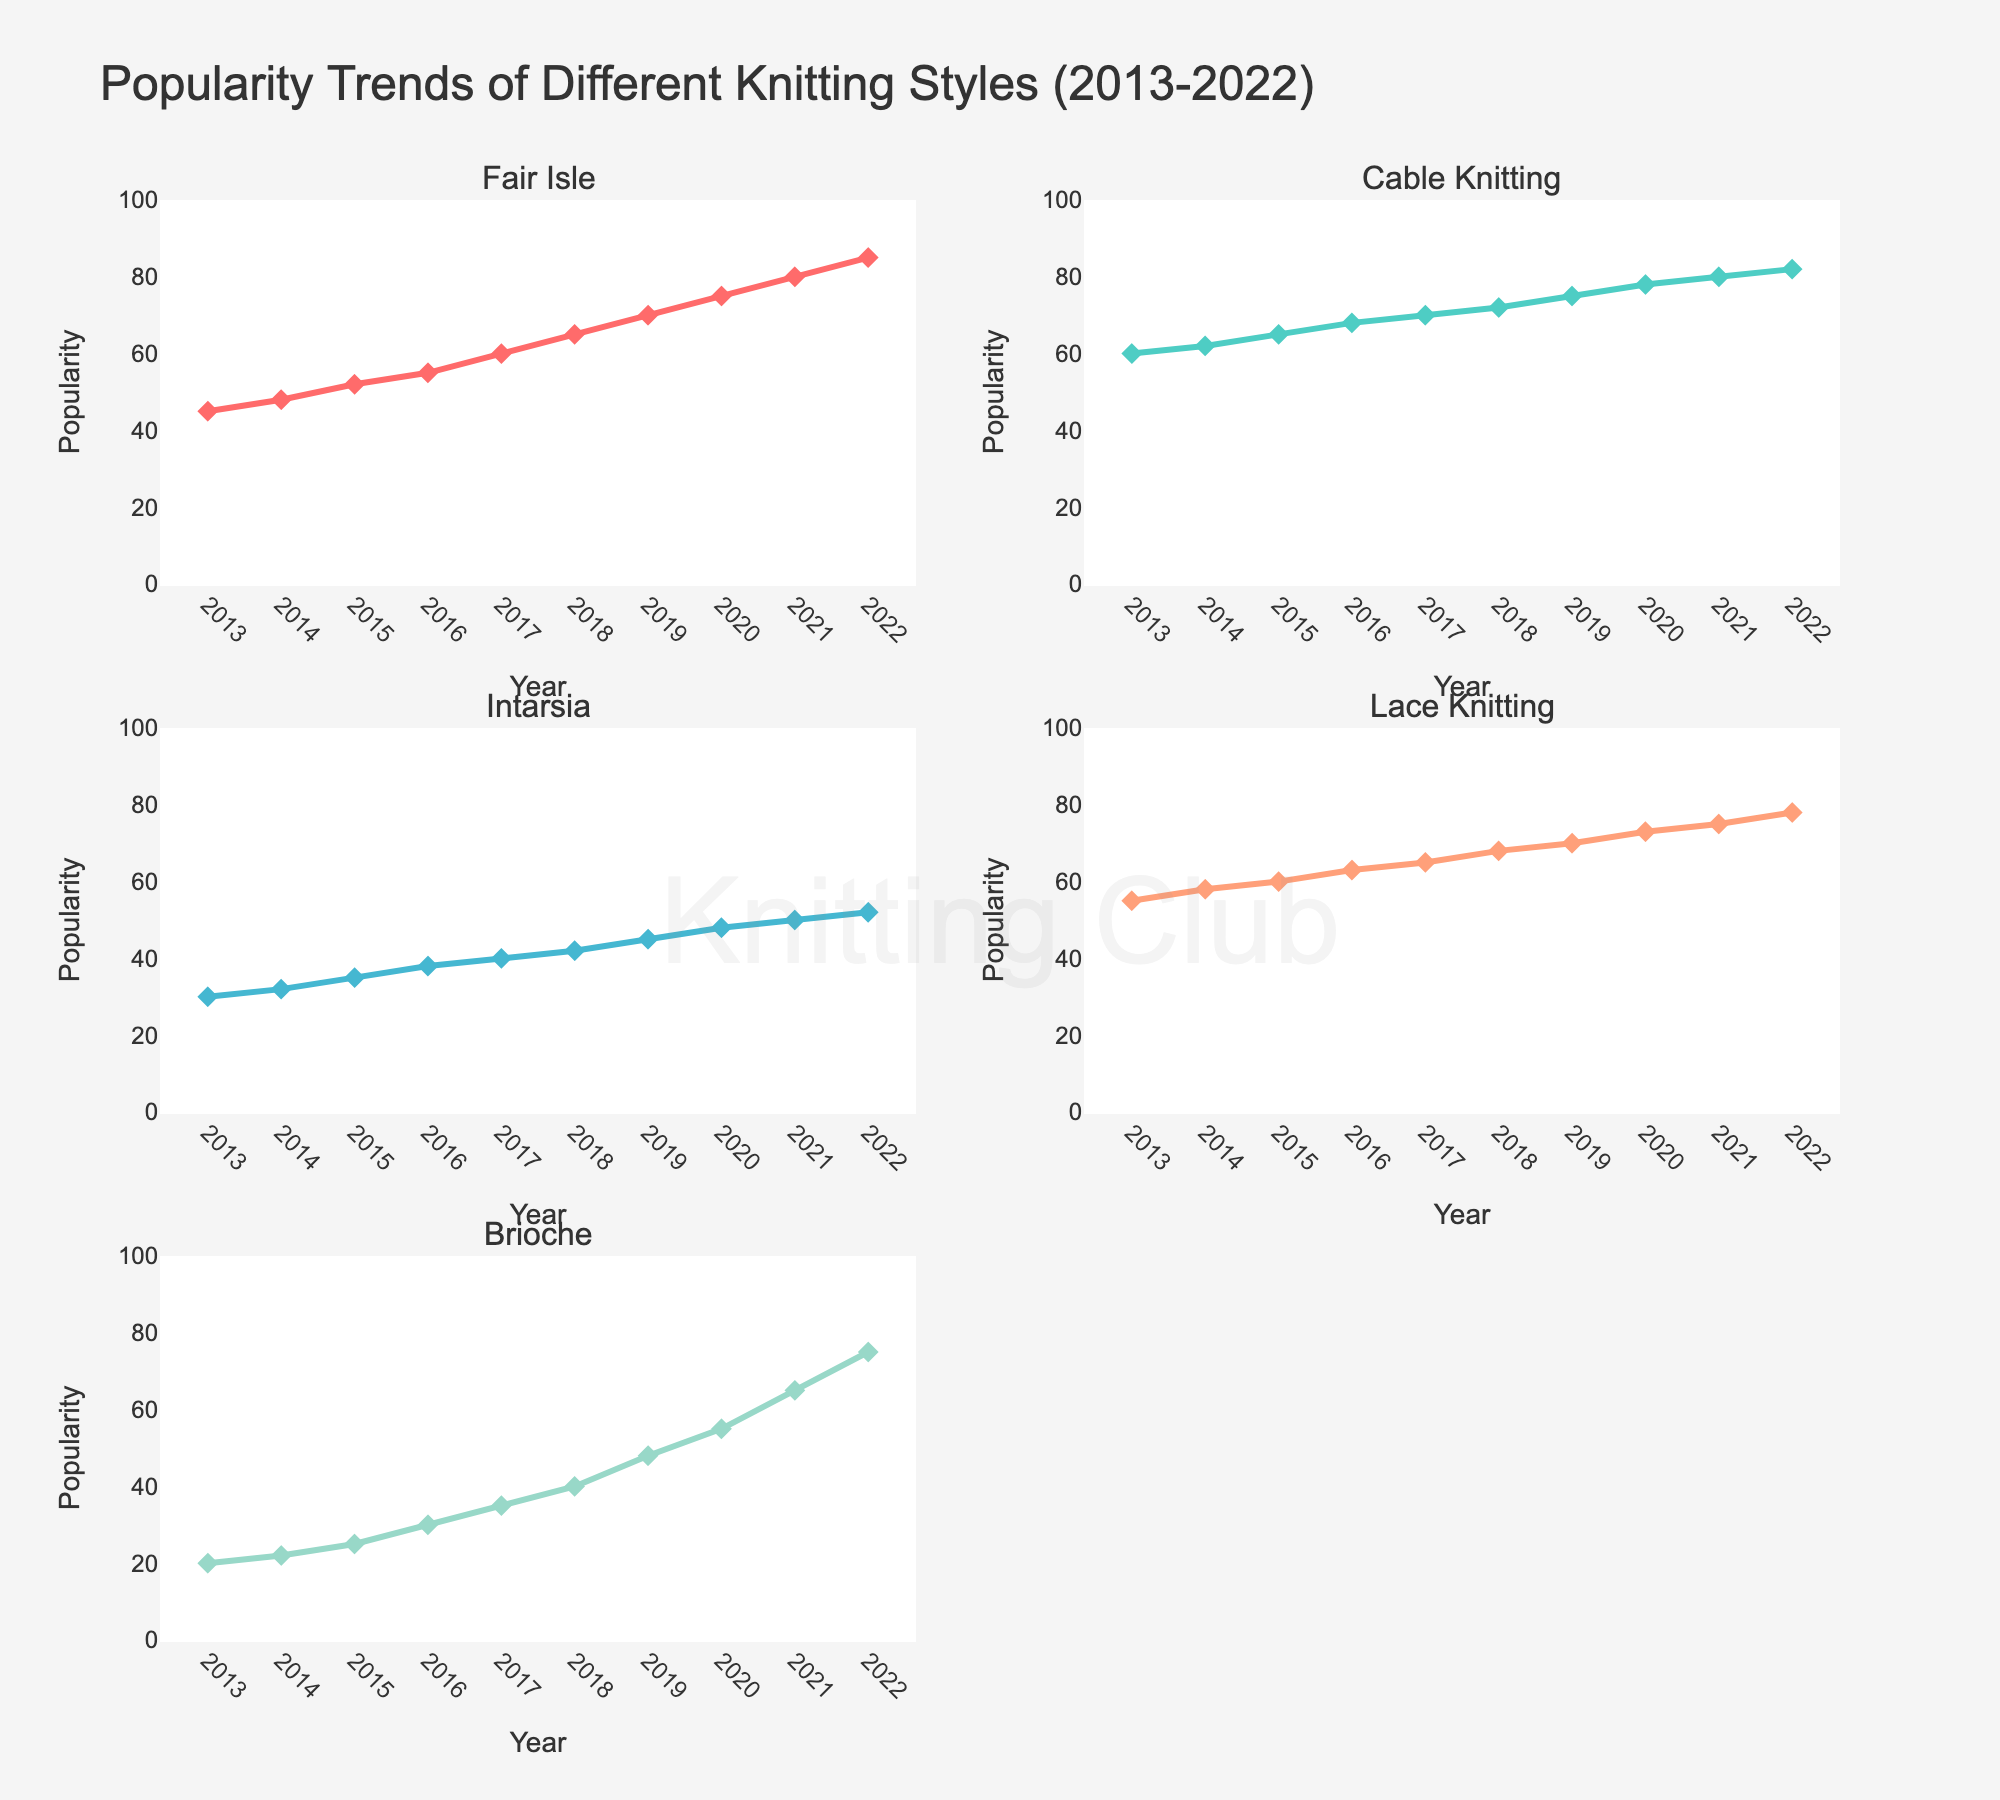What is the title of the figure? The title is usually located at the top of the figure. In this case, it is stated as "Popularity Trends of Different Knitting Styles (2013-2022)".
Answer: Popularity Trends of Different Knitting Styles (2013-2022) What is the general trend for Lace Knitting from 2013 to 2022? By examining the Lace Knitting line plot across the years, we can see the line is increasing steadily over the period. This indicates a rising trend in popularity.
Answer: Increasing Which knitting style had the lowest popularity in 2013 and what was its score? We can look at the data points for 2013, which are at the leftmost part of each subplot. The lowest value among them is 20 for Brioche.
Answer: Brioche, 20 Between Fair Isle and Intarsia, which style saw a more significant increase in popularity from 2013 to 2022? We can calculate the difference between 2022 and 2013 for both styles from the figure. Fair Isle increased from 45 to 85 (a 40-point increase), whereas Intarsia rose from 30 to 52 (a 22-point increase). Hence, Fair Isle saw a more significant increase.
Answer: Fair Isle Which year did Cable Knitting reach a popularity of 70? By tracing the Cable Knitting line, we look for the point where its value is 70; this occurred in 2017.
Answer: 2017 What is the average popularity of Brioche from 2013 to 2022? To calculate this, we sum all the Brioche popularity values (20+22+25+30+35+40+48+55+65+75=415) and divide it by the number of years (10). So, the average is 415/10 = 41.5.
Answer: 41.5 Compare the popularity trends of Fair Isle and Lace Knitting in the years 2020 to 2022. Which one increased more? For Fair Isle, the values from 2020 to 2022 are 75 to 85, an increase of 10. For Lace Knitting, the values are 73 to 78, an increase of 5. Therefore, Fair Isle increased more.
Answer: Fair Isle Which knitting style shows the most consistent increase in popularity across all years? By observing the general shape of each line, Cable Knitting consistently rises every year without any drops, indicating a steady increase.
Answer: Cable Knitting Are any knitting styles nearing a popularity score of 100 by 2022? By examining the popularity scores at the end points of each line plot in 2022, we see that none of the knitting styles have reached or are very close to 100, with the highest being 85.
Answer: No 